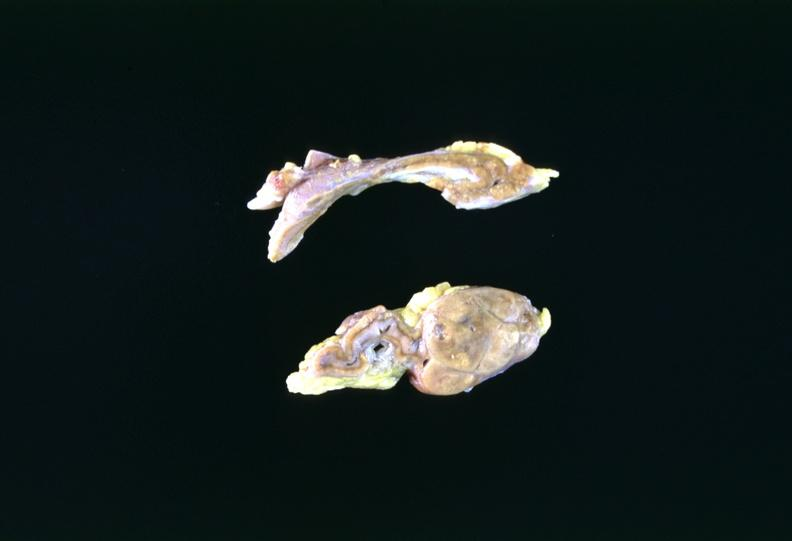what is present?
Answer the question using a single word or phrase. Endocrine 